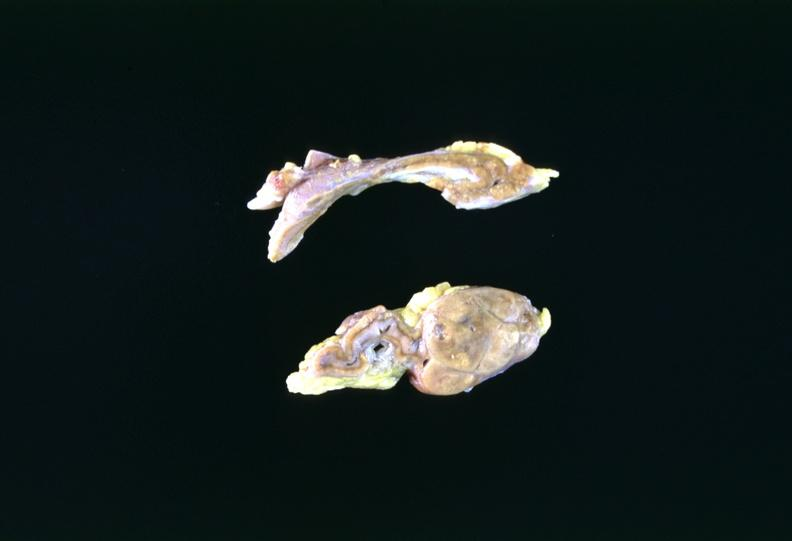what is present?
Answer the question using a single word or phrase. Endocrine 